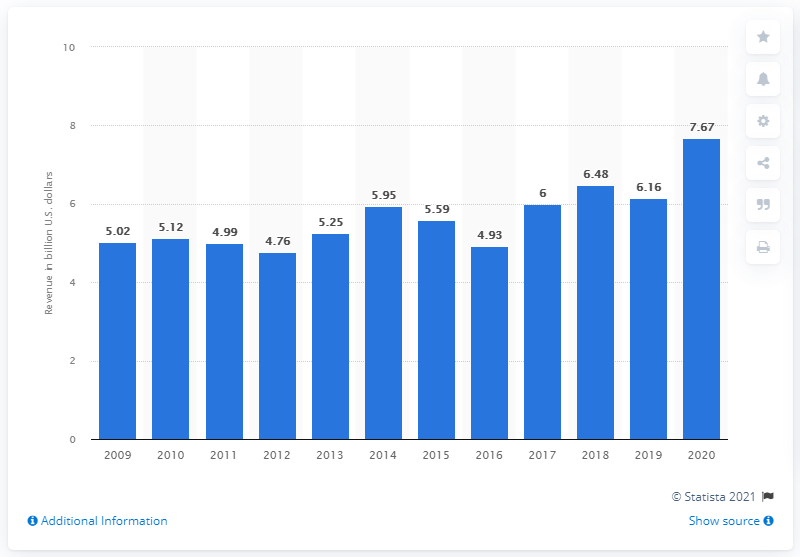Specify some key components in this picture. Morgan Stanley's investment banking division's revenue in 2020 was 7.67 billion U.S. dollars. 